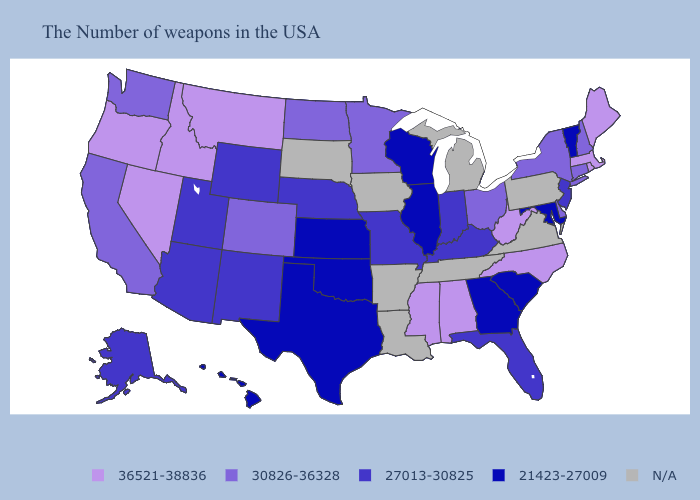Among the states that border Florida , which have the highest value?
Quick response, please. Alabama. Name the states that have a value in the range 27013-30825?
Quick response, please. New Jersey, Florida, Kentucky, Indiana, Missouri, Nebraska, Wyoming, New Mexico, Utah, Arizona, Alaska. What is the value of Louisiana?
Write a very short answer. N/A. What is the highest value in the USA?
Give a very brief answer. 36521-38836. Does the first symbol in the legend represent the smallest category?
Give a very brief answer. No. Which states hav the highest value in the MidWest?
Write a very short answer. Ohio, Minnesota, North Dakota. Does Minnesota have the lowest value in the USA?
Be succinct. No. Name the states that have a value in the range 30826-36328?
Be succinct. New Hampshire, Connecticut, New York, Delaware, Ohio, Minnesota, North Dakota, Colorado, California, Washington. How many symbols are there in the legend?
Concise answer only. 5. What is the lowest value in the USA?
Quick response, please. 21423-27009. What is the lowest value in states that border New Hampshire?
Concise answer only. 21423-27009. Is the legend a continuous bar?
Be succinct. No. 